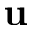<formula> <loc_0><loc_0><loc_500><loc_500>u</formula> 